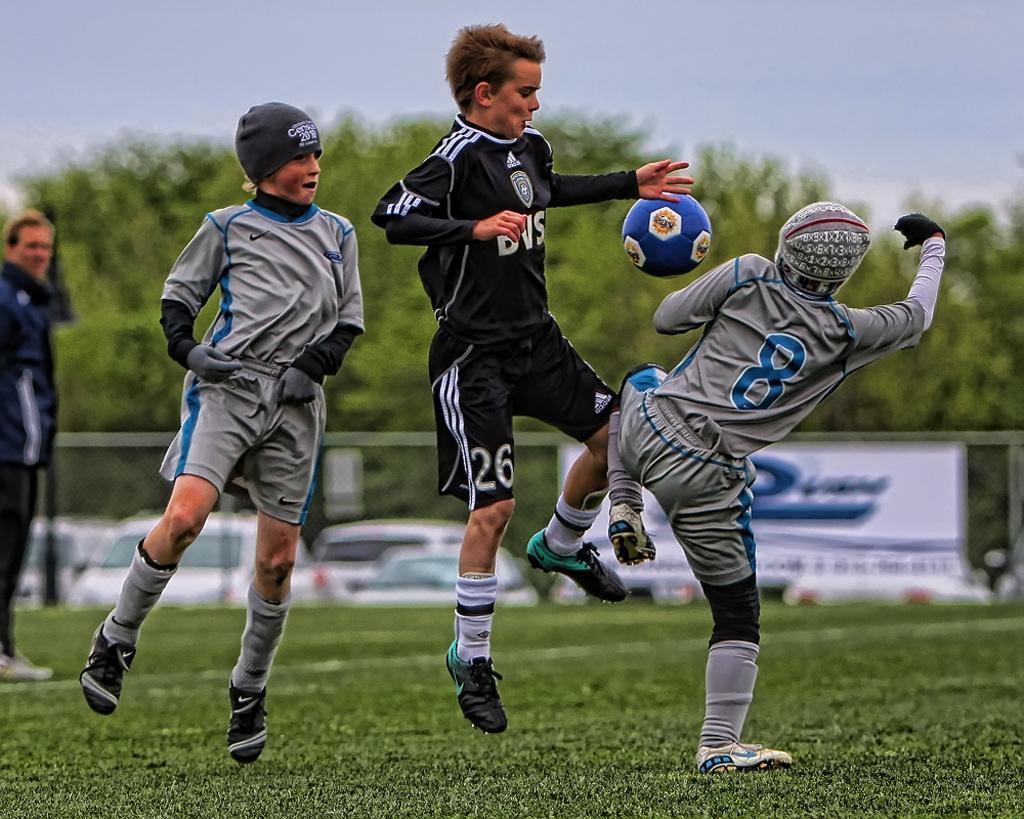In one or two sentences, can you explain what this image depicts? In this picture the boys are playing the football game. The floor is full grass, in the background there are trees, and sky is full of clouds. 